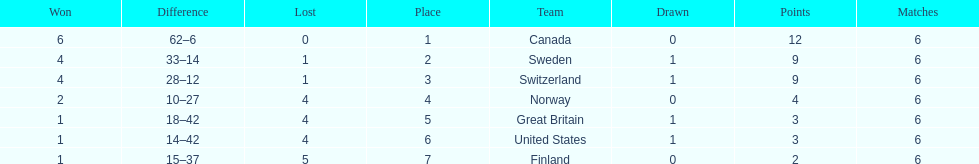What was the number of points won by great britain? 3. 